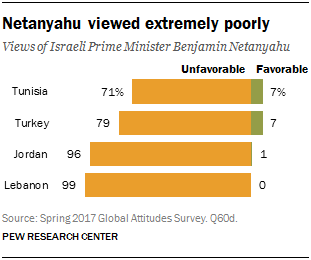Outline some significant characteristics in this image. Out of the countries listed, 2 countries have a favorable value below 7. The country with the highest sum value of unfavourable and favourable opinions is Lebanon. 